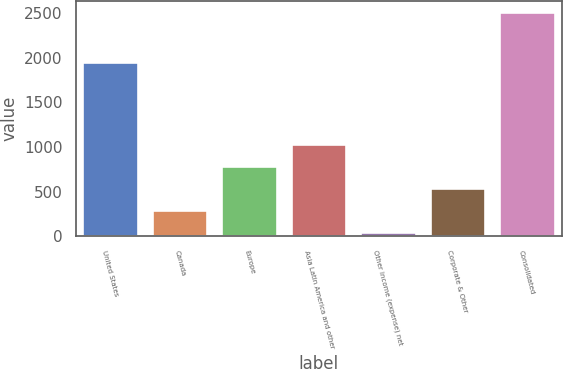<chart> <loc_0><loc_0><loc_500><loc_500><bar_chart><fcel>United States<fcel>Canada<fcel>Europe<fcel>Asia Latin America and other<fcel>Other income (expense) net<fcel>Corporate & Other<fcel>Consolidated<nl><fcel>1953.1<fcel>296.72<fcel>787.76<fcel>1033.28<fcel>51.2<fcel>542.24<fcel>2506.4<nl></chart> 